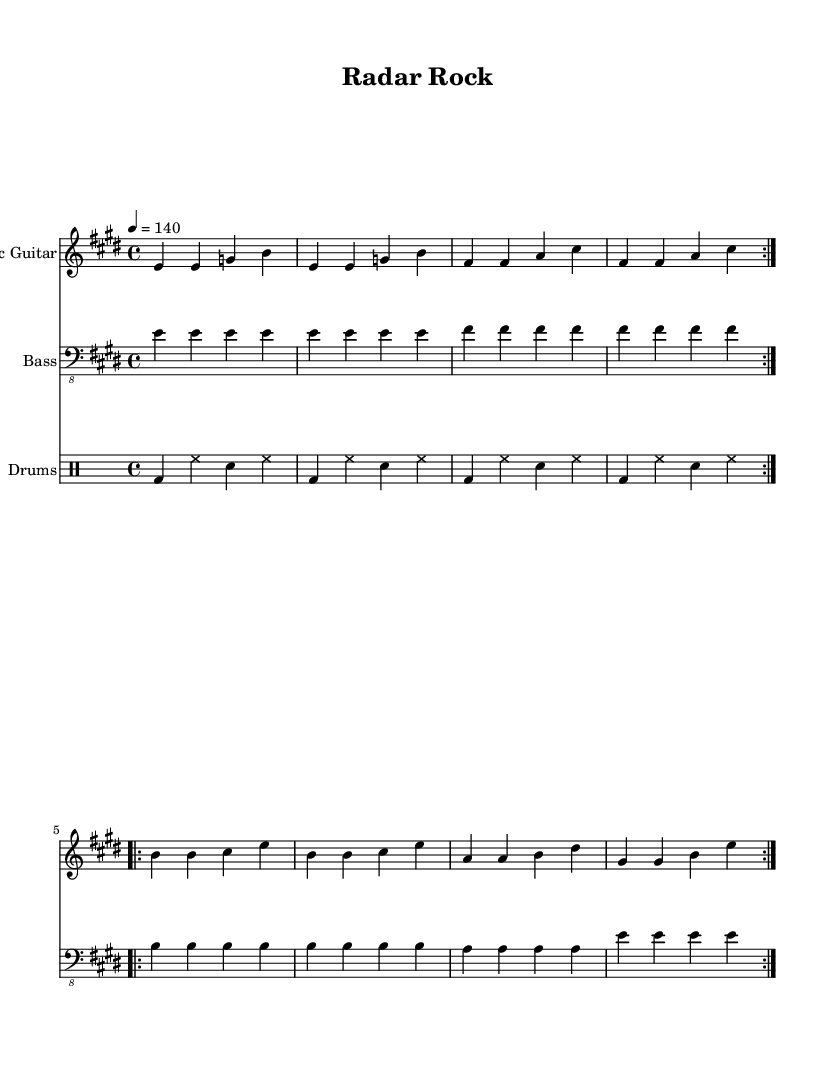What is the key signature of this music? The key signature is E major, which has four sharps: F#, C#, G#, and D#. This can be determined by looking at the key signature notation at the beginning of the sheet music.
Answer: E major What is the time signature of this music? The time signature is 4/4, which means there are four beats in each measure and the quarter note receives one beat. This information is indicated at the beginning of the music right after the key signature.
Answer: 4/4 What is the tempo marking for this piece? The tempo marking is 140 beats per minute (bpm), indicated by the notation "4 = 140" in the tempo section of the score. This signifies the speed at which the music should be played.
Answer: 140 How many measures are in the electric guitar part? The electric guitar part consists of 12 measures, as identified by counting the groupings of notes separated by vertical lines throughout the guitar staff.
Answer: 12 What rhythmic pattern do the drums follow? The rhythm pattern for the drums consists of bass drum on the first beat and snare drum on the third beat of each measure, which is a common rock drumming pattern. This is deduced by analyzing the drum notation in the drum staff.
Answer: Bass-snare How does the bass guitar primarily contribute to the overall feel of the piece? The bass guitar contributes by playing consistently on each beat with long sustained notes, creating a driving and solid foundation for the energetic rock feel. This is evident from the repeated quarter notes throughout its part.
Answer: Driving foundation What role does the electric guitar play in this composition? The electric guitar plays a melodic role, providing energetic riffs that celebrate teamwork, as indicated by the repeating and harmonizing patterns throughout its part. This is inferred from the rhythmic and melodic complexity of its notations.
Answer: Melodic role 